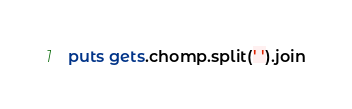Convert code to text. <code><loc_0><loc_0><loc_500><loc_500><_Ruby_>puts gets.chomp.split(' ').join</code> 